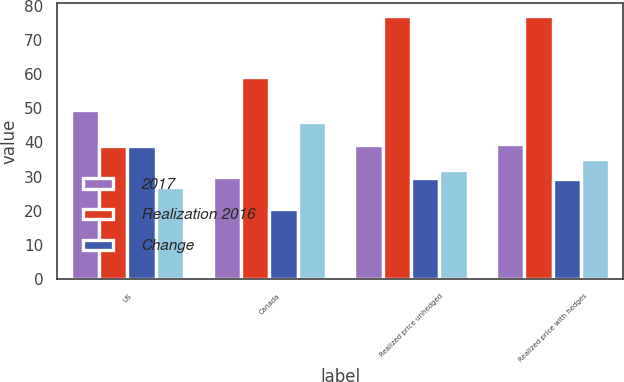Convert chart to OTSL. <chart><loc_0><loc_0><loc_500><loc_500><stacked_bar_chart><ecel><fcel>US<fcel>Canada<fcel>Realized price unhedged<fcel>Realized price with hedges<nl><fcel>2017<fcel>49.41<fcel>29.99<fcel>39.23<fcel>39.46<nl><fcel>Realization 2016<fcel>38.92<fcel>59<fcel>77<fcel>77<nl><fcel>Change<fcel>38.92<fcel>20.53<fcel>29.65<fcel>29.22<nl><fcel>nan<fcel>27<fcel>46<fcel>32<fcel>35<nl></chart> 